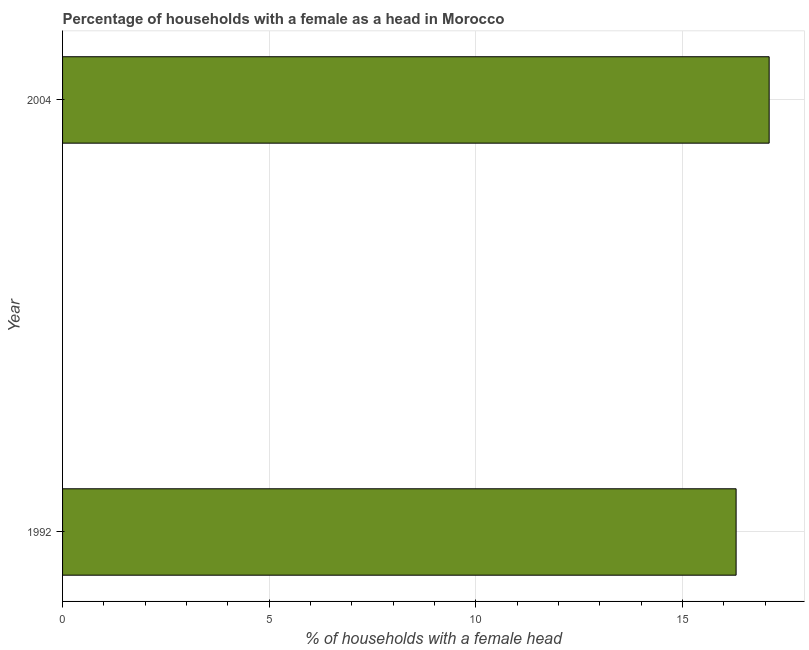Does the graph contain grids?
Provide a succinct answer. Yes. What is the title of the graph?
Keep it short and to the point. Percentage of households with a female as a head in Morocco. What is the label or title of the X-axis?
Your answer should be very brief. % of households with a female head. What is the label or title of the Y-axis?
Give a very brief answer. Year. Across all years, what is the maximum number of female supervised households?
Your response must be concise. 17.1. What is the sum of the number of female supervised households?
Your answer should be compact. 33.4. What is the median number of female supervised households?
Provide a short and direct response. 16.7. What is the ratio of the number of female supervised households in 1992 to that in 2004?
Provide a succinct answer. 0.95. How many bars are there?
Your answer should be very brief. 2. Are all the bars in the graph horizontal?
Make the answer very short. Yes. How many years are there in the graph?
Provide a short and direct response. 2. What is the difference between two consecutive major ticks on the X-axis?
Your answer should be compact. 5. Are the values on the major ticks of X-axis written in scientific E-notation?
Offer a very short reply. No. What is the % of households with a female head in 2004?
Give a very brief answer. 17.1. What is the ratio of the % of households with a female head in 1992 to that in 2004?
Keep it short and to the point. 0.95. 